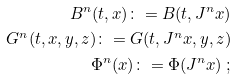Convert formula to latex. <formula><loc_0><loc_0><loc_500><loc_500>B ^ { n } ( t , x ) \colon = B ( t , J ^ { n } x ) \\ G ^ { n } ( t , x , y , z ) \colon = G ( t , J ^ { n } x , y , z ) \\ \Phi ^ { n } ( x ) \colon = \Phi ( J ^ { n } x ) \ ;</formula> 